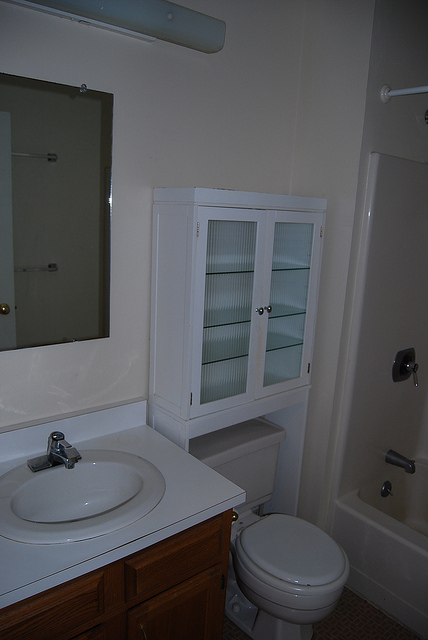<image>How many shelves are in the cabinet with the glass doors? I don't know exactly how many shelves are in the cabinet with the glass doors as it may be either 3 or 4. What shape is on the title to the right of the spigot? I don't know the shape on the title to the right of the spigot. It can be a rectangle, square or an oval. How many shelves are in the cabinet with the glass doors? It is not clear how many shelves are in the cabinet with the glass doors. It can be seen both 3 and 4 shelves. What shape is on the title to the right of the spigot? I am not sure what shape is on the title to the right of the spigot. There are different possibilities like rectangle, square, oval or circular. 